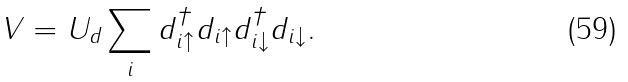Convert formula to latex. <formula><loc_0><loc_0><loc_500><loc_500>V = U _ { d } \sum _ { i } d ^ { \dag } _ { i \uparrow } d _ { i \uparrow } d ^ { \dag } _ { i \downarrow } d _ { i \downarrow } .</formula> 